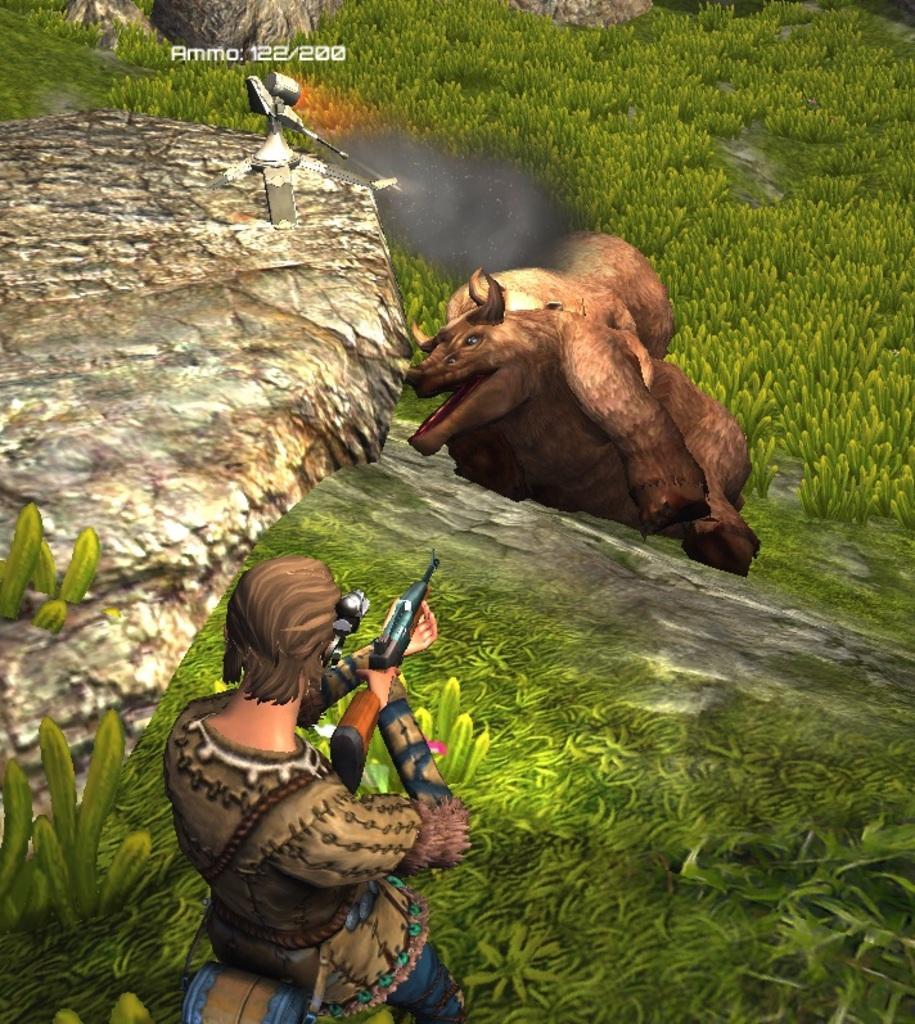Could you give a brief overview of what you see in this image? In this image there is an animation picture of a person holding a gun is shooting at an animal in front of him, in this image there are rocks and plants. 